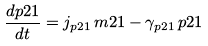Convert formula to latex. <formula><loc_0><loc_0><loc_500><loc_500>\frac { d p 2 1 } { d t } = j _ { p 2 1 } \, m 2 1 - \gamma _ { p 2 1 } \, p 2 1</formula> 